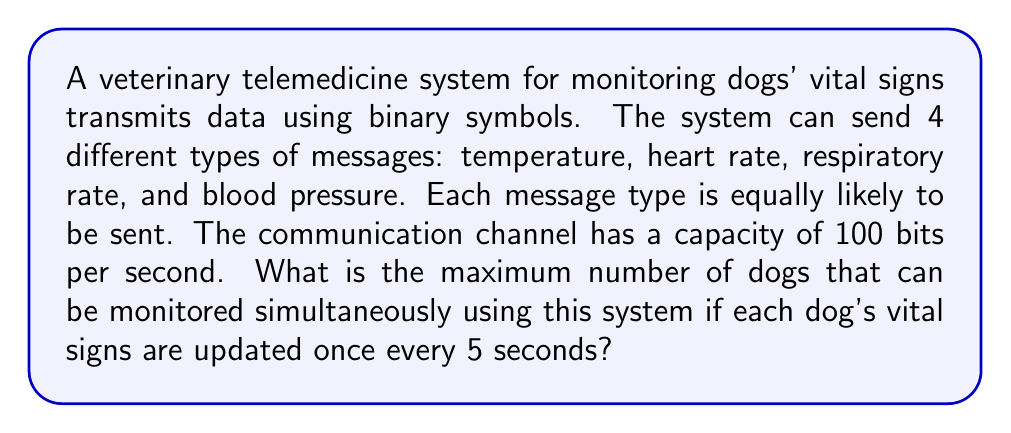Provide a solution to this math problem. To solve this problem, we need to follow these steps:

1. Calculate the information content of each message:
   Since there are 4 equally likely message types, the information content of each message is:
   $$H = -\log_2(\frac{1}{4}) = 2 \text{ bits}$$

2. Determine the information rate required for one dog:
   Each dog requires 4 messages (one for each vital sign) every 5 seconds.
   Information rate for one dog = $\frac{4 \text{ messages} \times 2 \text{ bits/message}}{5 \text{ seconds}} = 1.6 \text{ bits/second}$

3. Calculate the maximum number of dogs that can be monitored:
   Given the channel capacity of 100 bits per second, we can determine the maximum number of dogs by dividing the capacity by the information rate required for one dog:

   $$\text{Max number of dogs} = \frac{\text{Channel capacity}}{\text{Information rate per dog}} = \frac{100 \text{ bits/second}}{1.6 \text{ bits/second/dog}}$$

4. Solve and round down to the nearest whole number:
   $$\text{Max number of dogs} = 62.5$$

   Since we can't monitor a fraction of a dog, we round down to 62 dogs.
Answer: The maximum number of dogs that can be monitored simultaneously is 62. 